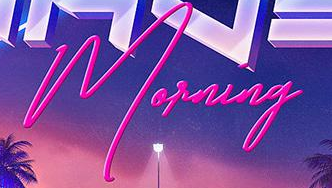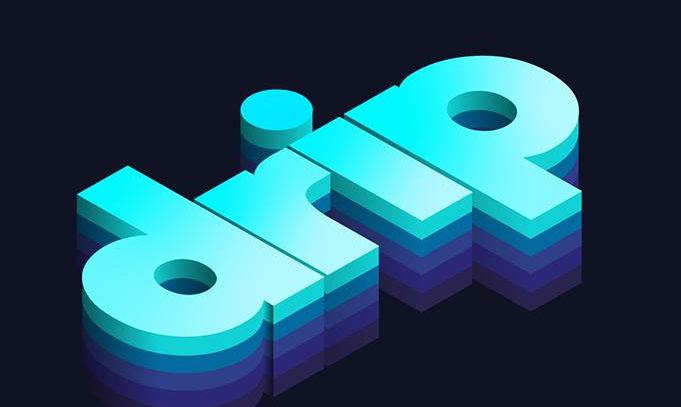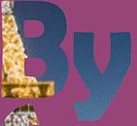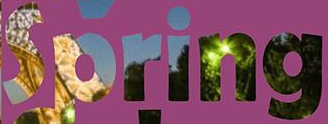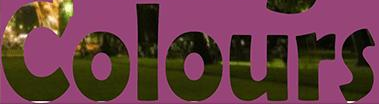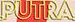What text is displayed in these images sequentially, separated by a semicolon? Morning; drip; By; Spring; Colours; PUTRA 